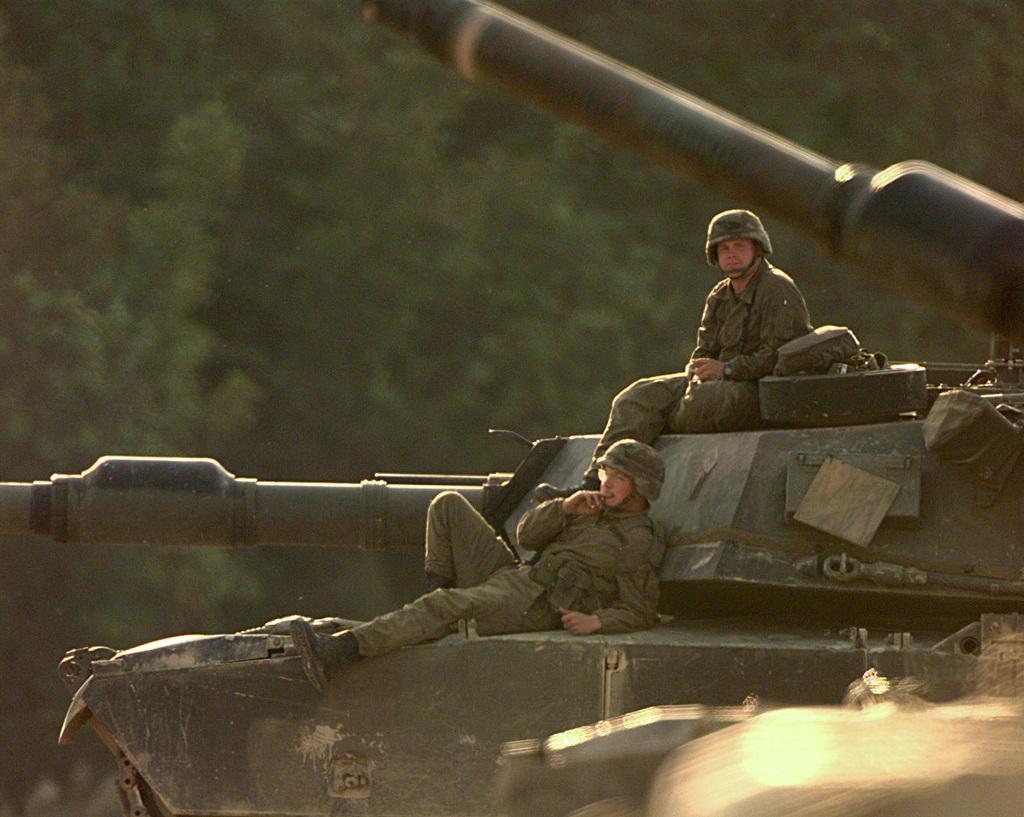Could you give a brief overview of what you see in this image? In this image we can see there are two persons sitting on top of the army tankers. In the background there are trees. 